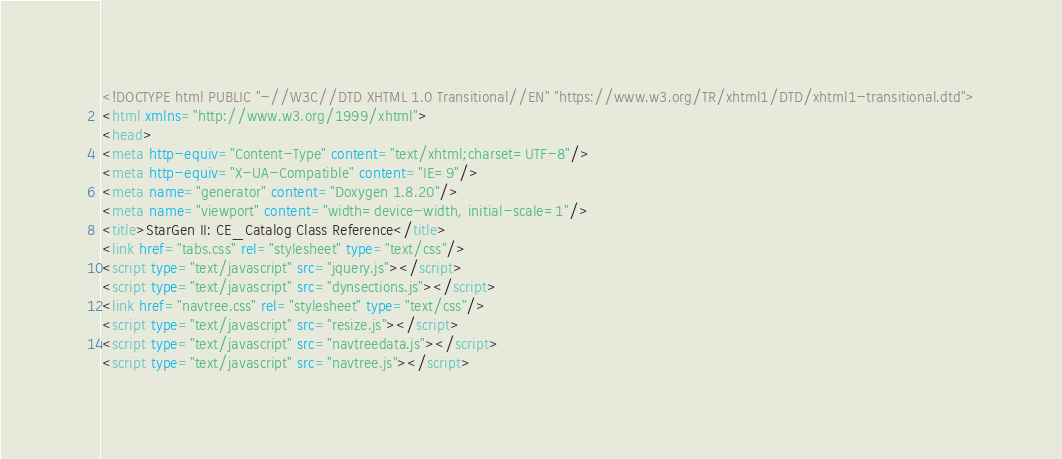<code> <loc_0><loc_0><loc_500><loc_500><_HTML_><!DOCTYPE html PUBLIC "-//W3C//DTD XHTML 1.0 Transitional//EN" "https://www.w3.org/TR/xhtml1/DTD/xhtml1-transitional.dtd">
<html xmlns="http://www.w3.org/1999/xhtml">
<head>
<meta http-equiv="Content-Type" content="text/xhtml;charset=UTF-8"/>
<meta http-equiv="X-UA-Compatible" content="IE=9"/>
<meta name="generator" content="Doxygen 1.8.20"/>
<meta name="viewport" content="width=device-width, initial-scale=1"/>
<title>StarGen II: CE_Catalog Class Reference</title>
<link href="tabs.css" rel="stylesheet" type="text/css"/>
<script type="text/javascript" src="jquery.js"></script>
<script type="text/javascript" src="dynsections.js"></script>
<link href="navtree.css" rel="stylesheet" type="text/css"/>
<script type="text/javascript" src="resize.js"></script>
<script type="text/javascript" src="navtreedata.js"></script>
<script type="text/javascript" src="navtree.js"></script></code> 